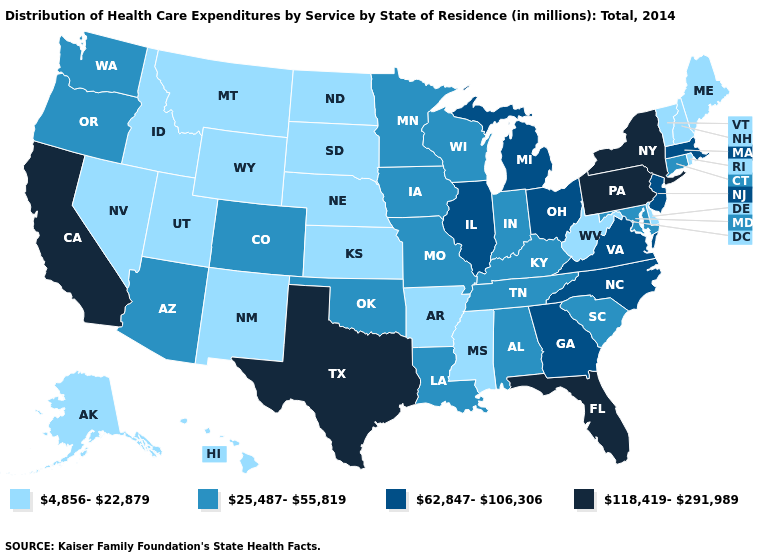What is the lowest value in the USA?
Write a very short answer. 4,856-22,879. Name the states that have a value in the range 118,419-291,989?
Short answer required. California, Florida, New York, Pennsylvania, Texas. Name the states that have a value in the range 4,856-22,879?
Quick response, please. Alaska, Arkansas, Delaware, Hawaii, Idaho, Kansas, Maine, Mississippi, Montana, Nebraska, Nevada, New Hampshire, New Mexico, North Dakota, Rhode Island, South Dakota, Utah, Vermont, West Virginia, Wyoming. Does Connecticut have the highest value in the USA?
Be succinct. No. What is the value of North Carolina?
Keep it brief. 62,847-106,306. What is the value of Washington?
Short answer required. 25,487-55,819. What is the lowest value in states that border Michigan?
Give a very brief answer. 25,487-55,819. What is the value of North Dakota?
Be succinct. 4,856-22,879. Among the states that border Vermont , does New Hampshire have the highest value?
Quick response, please. No. Among the states that border North Dakota , does Montana have the lowest value?
Be succinct. Yes. Name the states that have a value in the range 62,847-106,306?
Concise answer only. Georgia, Illinois, Massachusetts, Michigan, New Jersey, North Carolina, Ohio, Virginia. What is the value of New Hampshire?
Be succinct. 4,856-22,879. Name the states that have a value in the range 4,856-22,879?
Write a very short answer. Alaska, Arkansas, Delaware, Hawaii, Idaho, Kansas, Maine, Mississippi, Montana, Nebraska, Nevada, New Hampshire, New Mexico, North Dakota, Rhode Island, South Dakota, Utah, Vermont, West Virginia, Wyoming. What is the highest value in the Northeast ?
Keep it brief. 118,419-291,989. What is the value of Nevada?
Answer briefly. 4,856-22,879. 